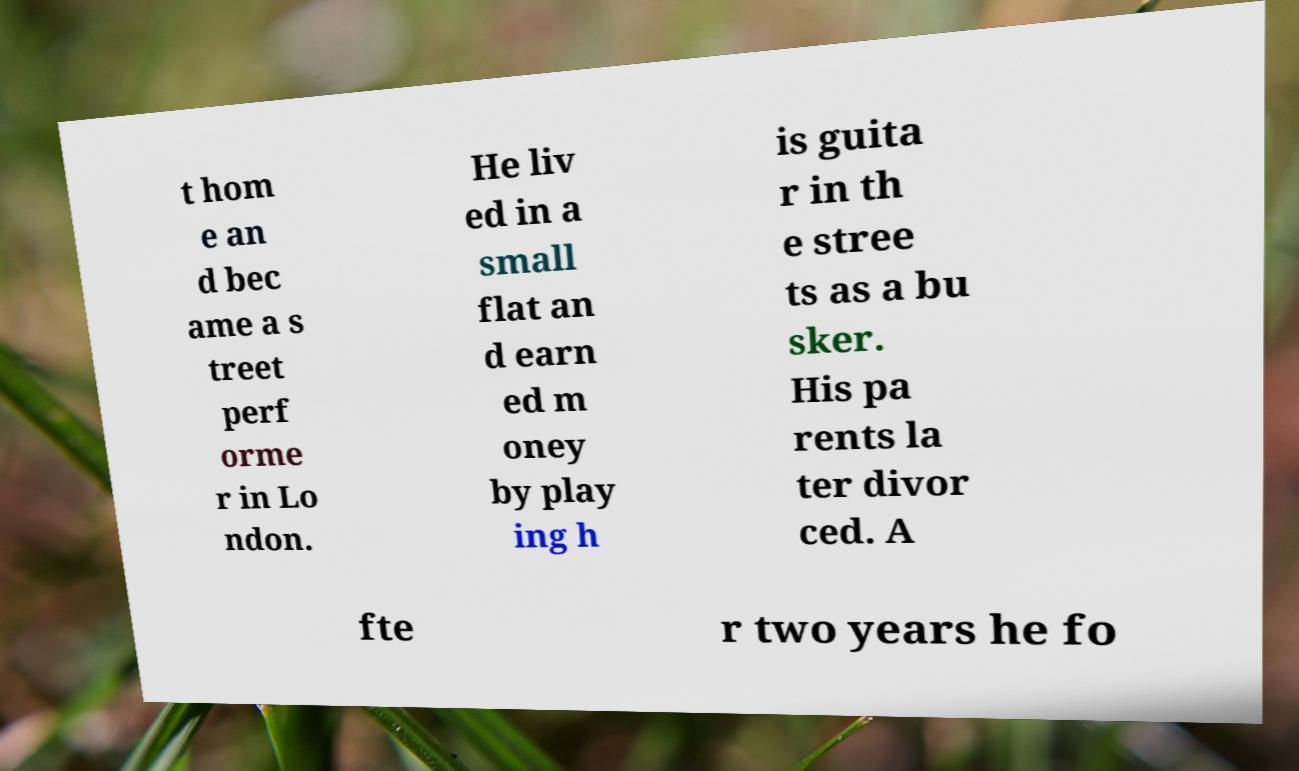Could you extract and type out the text from this image? t hom e an d bec ame a s treet perf orme r in Lo ndon. He liv ed in a small flat an d earn ed m oney by play ing h is guita r in th e stree ts as a bu sker. His pa rents la ter divor ced. A fte r two years he fo 